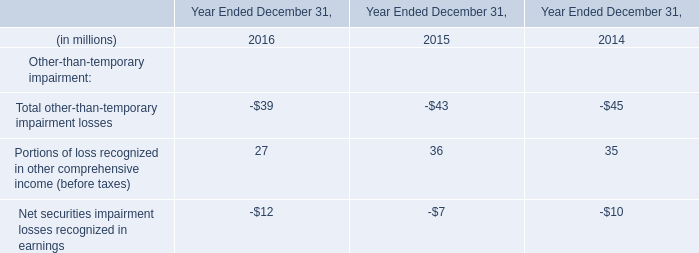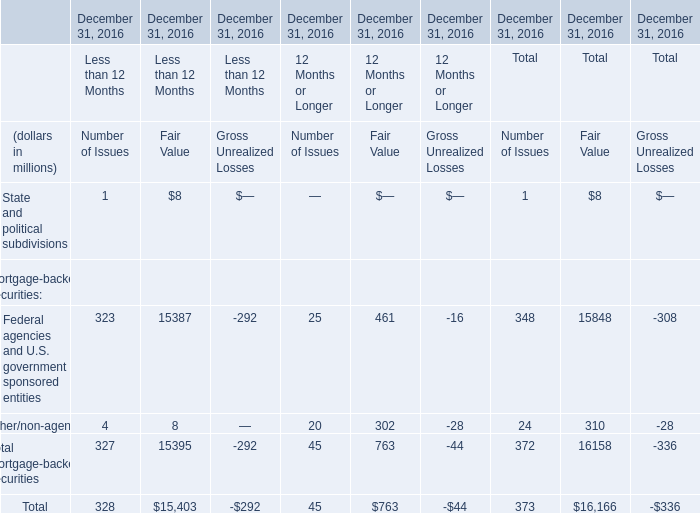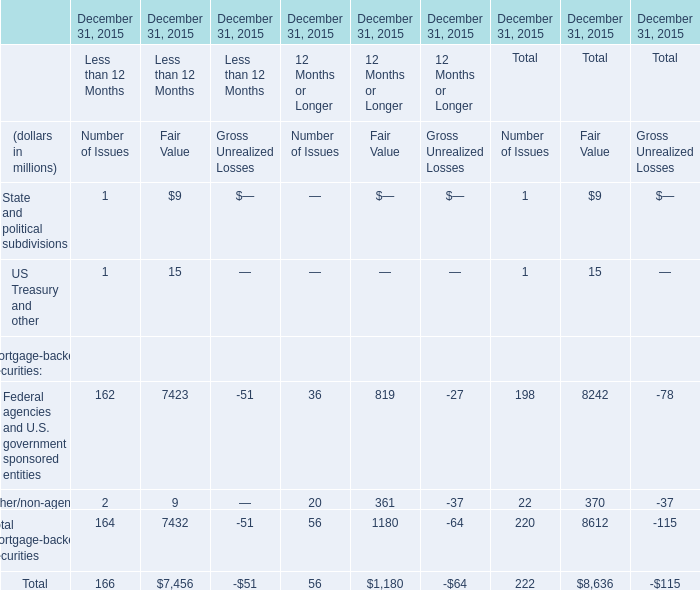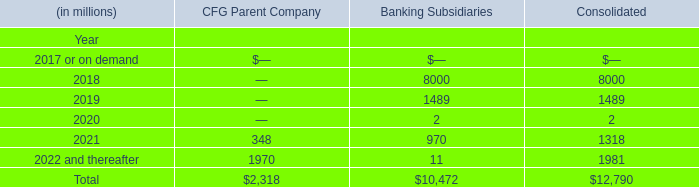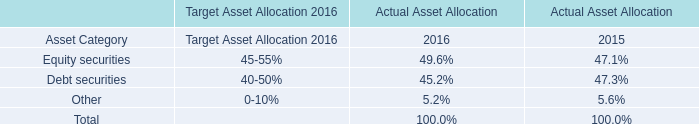What's the sum of all Number of Issues that are greater than 0 in 2015 for Less than 12 Months? (in million) 
Answer: 166. 